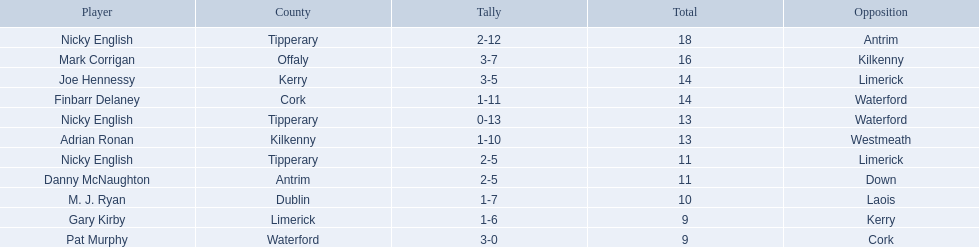Who are all the players? Nicky English, Mark Corrigan, Joe Hennessy, Finbarr Delaney, Nicky English, Adrian Ronan, Nicky English, Danny McNaughton, M. J. Ryan, Gary Kirby, Pat Murphy. How many points did they receive? 18, 16, 14, 14, 13, 13, 11, 11, 10, 9, 9. Would you mind parsing the complete table? {'header': ['Player', 'County', 'Tally', 'Total', 'Opposition'], 'rows': [['Nicky English', 'Tipperary', '2-12', '18', 'Antrim'], ['Mark Corrigan', 'Offaly', '3-7', '16', 'Kilkenny'], ['Joe Hennessy', 'Kerry', '3-5', '14', 'Limerick'], ['Finbarr Delaney', 'Cork', '1-11', '14', 'Waterford'], ['Nicky English', 'Tipperary', '0-13', '13', 'Waterford'], ['Adrian Ronan', 'Kilkenny', '1-10', '13', 'Westmeath'], ['Nicky English', 'Tipperary', '2-5', '11', 'Limerick'], ['Danny McNaughton', 'Antrim', '2-5', '11', 'Down'], ['M. J. Ryan', 'Dublin', '1-7', '10', 'Laois'], ['Gary Kirby', 'Limerick', '1-6', '9', 'Kerry'], ['Pat Murphy', 'Waterford', '3-0', '9', 'Cork']]} And which player received 10 points? M. J. Ryan. 